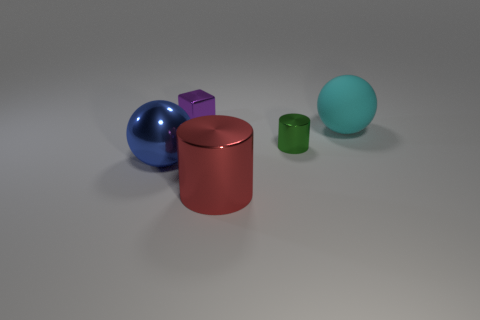There is a tiny thing that is in front of the purple metallic thing; is it the same shape as the purple metal thing?
Make the answer very short. No. What shape is the big metallic object to the left of the cylinder that is in front of the large blue metallic ball?
Your response must be concise. Sphere. Is there anything else that has the same shape as the green thing?
Keep it short and to the point. Yes. There is another thing that is the same shape as the cyan object; what is its color?
Your answer should be very brief. Blue. There is a rubber thing; is it the same color as the sphere to the left of the small green shiny thing?
Ensure brevity in your answer.  No. There is a large object that is to the right of the big blue metallic thing and to the left of the matte ball; what shape is it?
Make the answer very short. Cylinder. Are there fewer blue metallic things than green rubber cubes?
Make the answer very short. No. Are there any tiny purple objects?
Make the answer very short. Yes. What number of other objects are there of the same size as the blue metallic ball?
Give a very brief answer. 2. Are the blue sphere and the object behind the large rubber object made of the same material?
Give a very brief answer. Yes. 